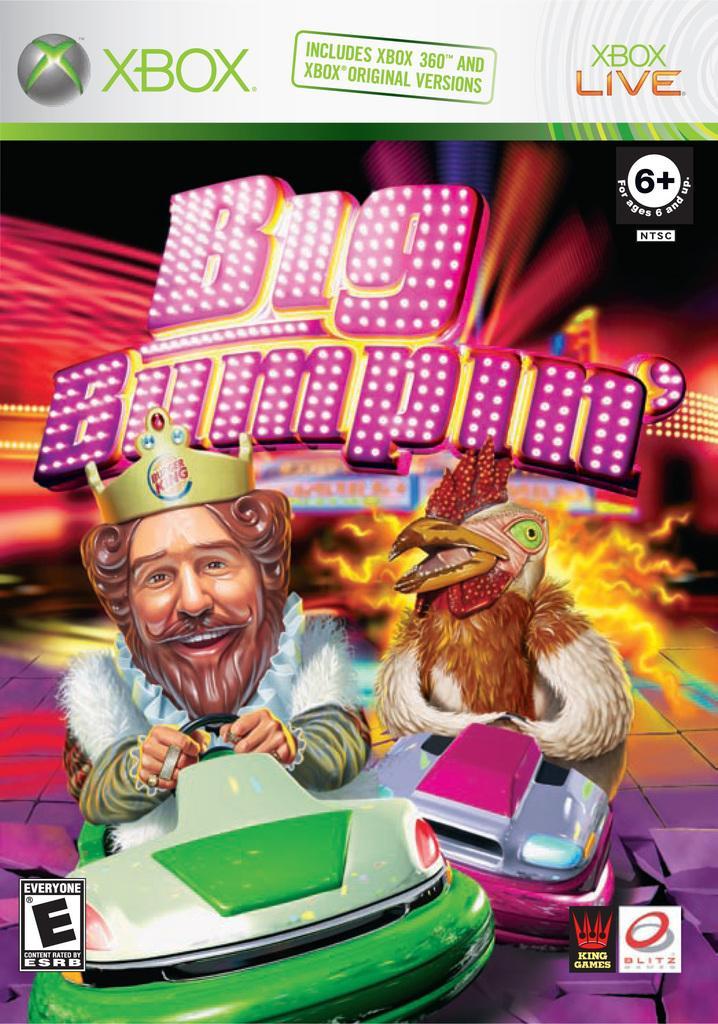Describe this image in one or two sentences. This image is an edited image. In this image there are two cartoon characters sitting in the cars. At the top of the image there is a text. 